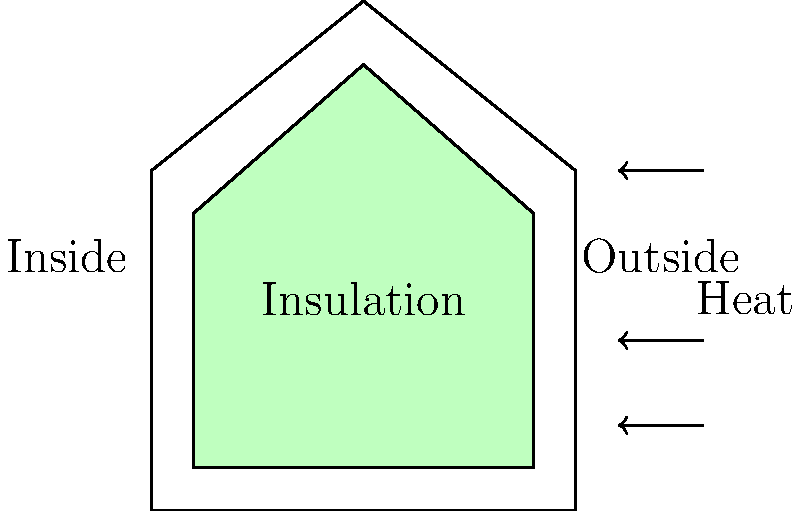You're considering adding insulation to your home to reduce heating costs. If the temperature difference between the inside and outside of your house is 20°C, and the thermal conductivity of the insulation material is 0.04 W/(m·K), what thickness of insulation (in cm) would you need to reduce the heat loss through a 10 m² wall to 80 W? To solve this problem, we'll use Fourier's Law of Heat Conduction:

$$ Q = k A \frac{\Delta T}{d} $$

Where:
- $Q$ is the heat transfer rate (W)
- $k$ is the thermal conductivity of the material (W/(m·K))
- $A$ is the area of the wall (m²)
- $\Delta T$ is the temperature difference (°C or K)
- $d$ is the thickness of the insulation (m)

We're given:
- $Q = 80$ W (desired heat loss)
- $k = 0.04$ W/(m·K)
- $A = 10$ m²
- $\Delta T = 20$ °C

Let's rearrange the equation to solve for $d$:

$$ d = k A \frac{\Delta T}{Q} $$

Now, let's substitute the values:

$$ d = 0.04 \text{ W/(m·K)} \times 10 \text{ m}² \times \frac{20 \text{ °C}}{80 \text{ W}} $$

$$ d = \frac{0.04 \times 10 \times 20}{80} \text{ m} $$

$$ d = 0.1 \text{ m} $$

To convert this to centimeters:

$$ d = 0.1 \text{ m} \times 100 \text{ cm/m} = 10 \text{ cm} $$

Therefore, you would need 10 cm of insulation to reduce the heat loss to 80 W.
Answer: 10 cm 